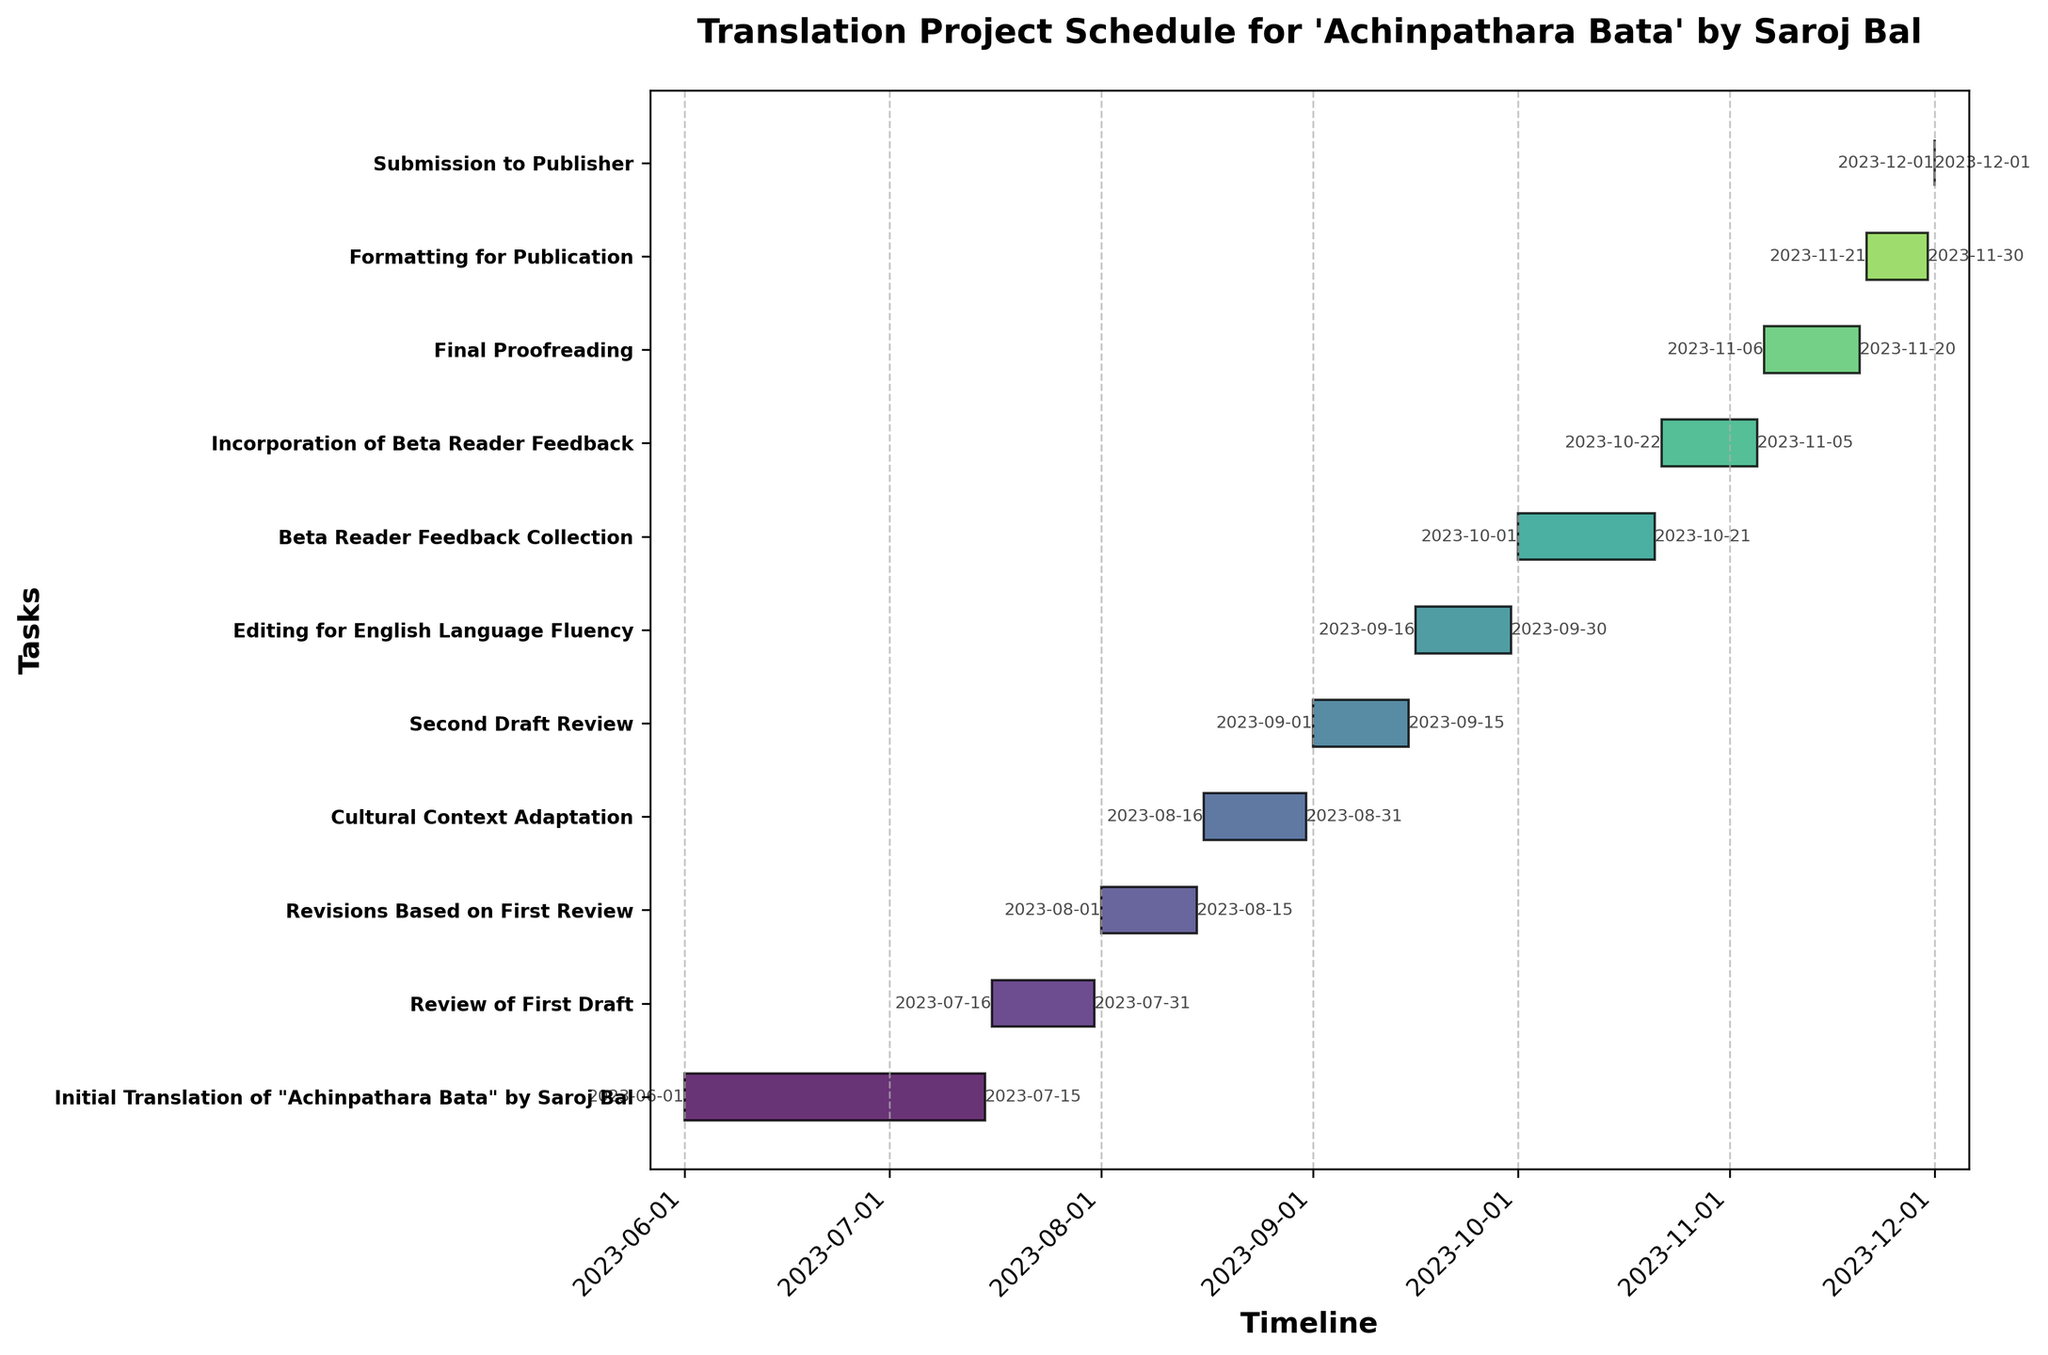When does the Initial Translation task start and end? The figure shows the start and end dates for each task. The Initial Translation task begins on 2023-06-01 and ends on 2023-07-15 as indicated next to the task bar.
Answer: 2023-06-01 to 2023-07-15 How long is the Cultural Context Adaptation phase in terms of days? The Cultural Context Adaptation phase runs from 2023-08-16 to 2023-08-31. To find the duration, count the number of days between the start and end dates inclusive. This gives 16 days in total.
Answer: 16 days Which task occurs immediately after the Second Draft Review? By following the timeline on the Gantt Chart, the task that comes directly after the Second Draft Review is "Editing for English Language Fluency," which starts on 2023-09-16.
Answer: Editing for English Language Fluency How many days are there between the end of Revisions Based on First Review and the start of Cultural Context Adaptation? The end date of the Revisions Based on First Review is 2023-08-15, and the start date of the Cultural Context Adaptation is 2023-08-16. Therefore, the gap between the two tasks is just 1 day.
Answer: 1 day Is there any overlap between the tasks? If so, which tasks are overlapping? Reviewing the Gantt Chart, we see that there is no overlap between any tasks. All tasks start immediately after the preceding task ends.
Answer: No overlap Which task has the shortest duration? To find the shortest duration task, compare the lengths of all task bars. "Submission to Publisher" is the shortest, with a duration of only 1 day on 2023-12-01.
Answer: Submission to Publisher Calculate the total duration of the project from start to end. The project starts on 2023-06-01 and ends on 2023-12-01. To find the total duration, count the number of days from the start date to the end date inclusive. The total project duration is 184 days.
Answer: 184 days What is the average duration of all tasks? Count the total number of tasks, which is 11. Calculate the duration of each task and then sum all the durations. Finally, divide the sum by the number of tasks. The total durations are: (45 + 16 + 15 + 16 + 15 + 15 + 21 + 15 + 15 + 10 + 1) = 184 days. The average is 184/11 = ~16.7 days.
Answer: ~16.7 days Which phases involve feedback incorporation or revision? The tasks involving feedback and revision can be identified by their names. These include "Revisions Based on First Review," "Second Draft Review," "Beta Reader Feedback Collection," and "Incorporation of Beta Reader Feedback."
Answer: Four phases 